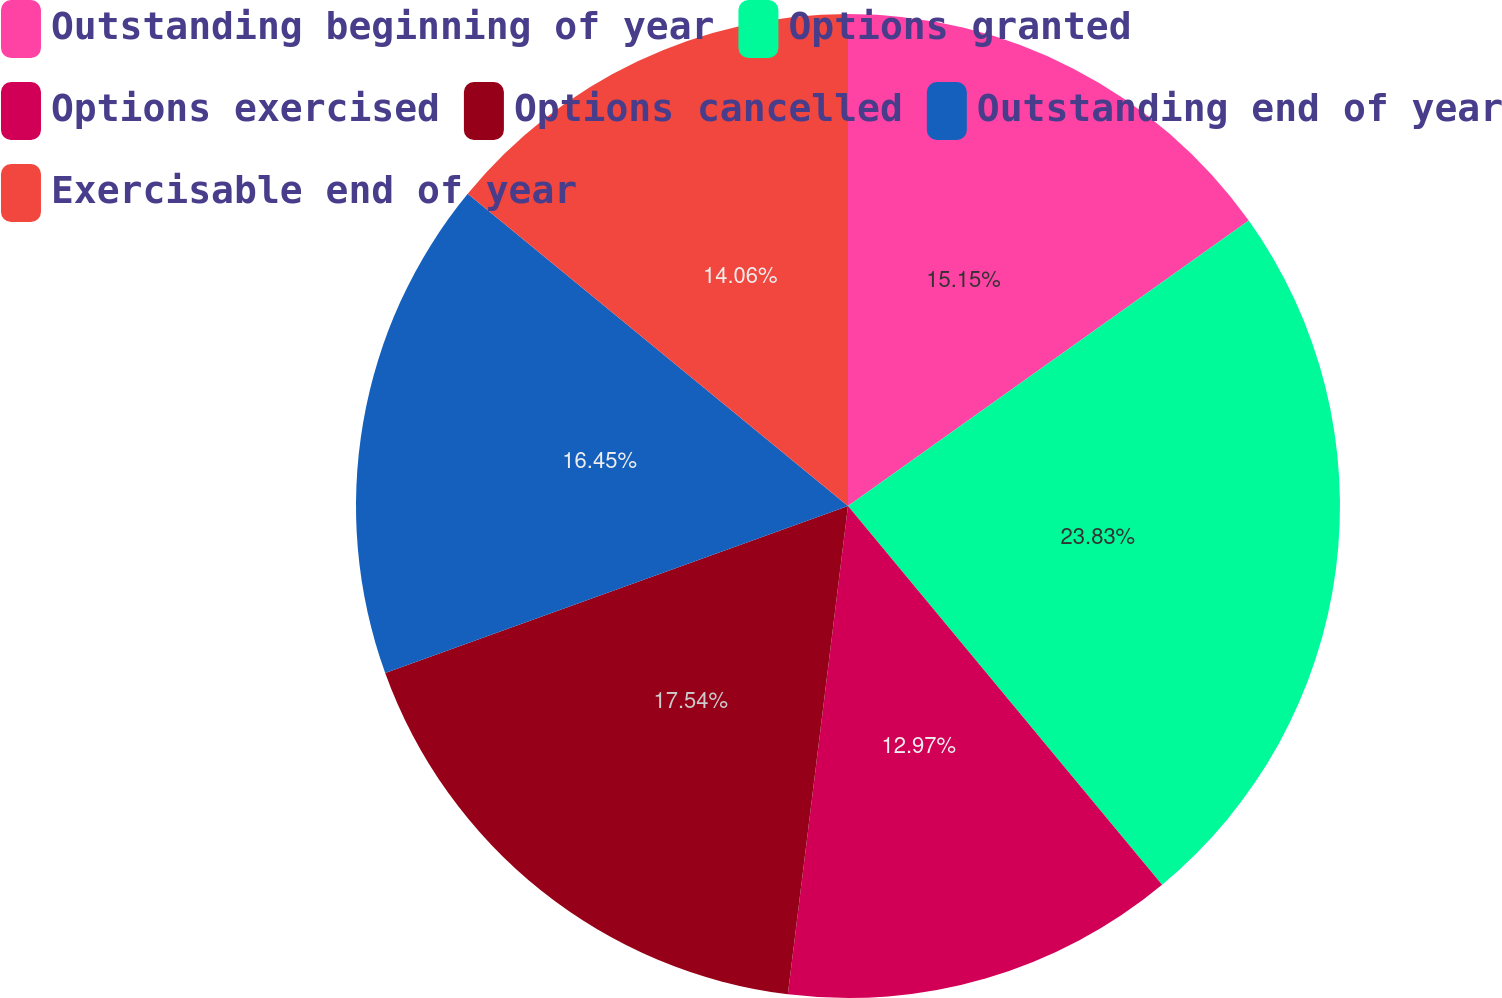<chart> <loc_0><loc_0><loc_500><loc_500><pie_chart><fcel>Outstanding beginning of year<fcel>Options granted<fcel>Options exercised<fcel>Options cancelled<fcel>Outstanding end of year<fcel>Exercisable end of year<nl><fcel>15.15%<fcel>23.83%<fcel>12.97%<fcel>17.54%<fcel>16.45%<fcel>14.06%<nl></chart> 